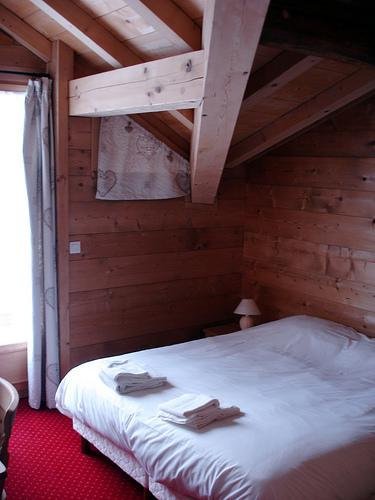How many white towels are there on the bed in the image? There are two stacks of white towels on the bed. Describe the bed's headboard and provide details about its material. The headboard of the bed is white and appears to be made of a fabric or upholstered material. What type of wall is in the room and provide a description of its appearance. The room has a wooden wall, most likely oak, with a knotty, rustic appearance. What are the main colors present in the room's decor? White, red, and wood tones are the main colors in the room's decor. Evaluate the ambiance or mood of the room shown in the image. The ambiance of the room is cozy and inviting, with warm colors and comfortable furnishings. What type of flooring is present in the room? The room has red carpet flooring with a touch of gold. Identify the light source in the image and describe its appearance. There is a small yellow bedside lamp near the bed, providing a warm, soft light. Describe the primary function of the objects found on the bed. The objects on the bed, including white sheets and towels, provide comfort, warmth, and cleanliness for the user. Do the curtains in the image have any pattern or print on them? Yes, the curtains have a pattern of hearts on them. Provide a short description of the room's main elements. The room features a white bed with towels on it, a small yellow bedside lamp, a wooden wall, red carpet, and a curtain with hearts. Is there a light switch present in the image? Yes, there is a light switch to the right of the door. Does the nightstand have a vase with flowers on it? The nightstand is mentioned to have a lamp on it, not a vase with flowers, so this instruction is false. Are there any unusual interactions or placements of objects in the image? No, the object placements appear normal. Which object is closest to the white bed? The small white lamp is closest to the white bed. What are the sizes of the white towels on the bed? There are different sizes of white towels present, such as Width:90 Height:90 and Width:97 Height:97. How many piles of white towels are on the bed? There are two piles of white towels on the bed. What type of sheets are on the bed? White sheets are on the bed. What type of room is the image taken in? The image is taken in a room under a roof. Evaluate the overall quality of the image. The image has average quality. Identify the objects present in the image. bed, towels, lamp, red carpet, wooden post, nightstand, chair, curtain, light switch, wall panel, rug, side table Identify the contents and location of the red polka dot rug. The red polka dot rug is located at coordinates X:29 Y:443 with Width:51 Height:51. Are the walls in the room made of concrete instead of wood? The captions say the walls are wooden, not concrete, so mentioning concrete walls is misleading. Detect any anomalies in the image. No anomalies detected. What is the general sentiment of the image? The general sentiment of the image is neutral and calm. Is there any text visible in the image? No visible text in the image. Do the curtains have stars instead of hearts on them? The caption mentions there are hearts on the curtains, so asking if there are stars on them is misleading. Is there a brown couch next to the bed? There's no mention of a couch in the image captions, so mentioning one with wrong attributes is misleading. Is the bed actually blue instead of white? The captions mention that the bed is white multiple times, so saying it's blue is a contradiction. What are the colors of the bed and the carpet in the picture? The bed is white and the carpet is red. What is the location of the small yellow bedside lamp? The small yellow bedside lamp is located at coordinates X:243 Y:282 Width:22 Height:22. What is the material of the wall by the bed? The wall material is most likely oak. Is there a window present in the image? The window is not visible, but curtains suggest there might be a window. Can you see the green and purple carpet in the room? The carpet is described as red and gold; not green and purple, asking for a green and purple carpet is wrong. What color is the curtain in the room? The curtain is white. Describe the main object and associated objects in the image. The main object is a white bed with white sheets and towels, and it is surrounded by a small lamp, a red carpet, a nightstand, a chair, and curtains. 